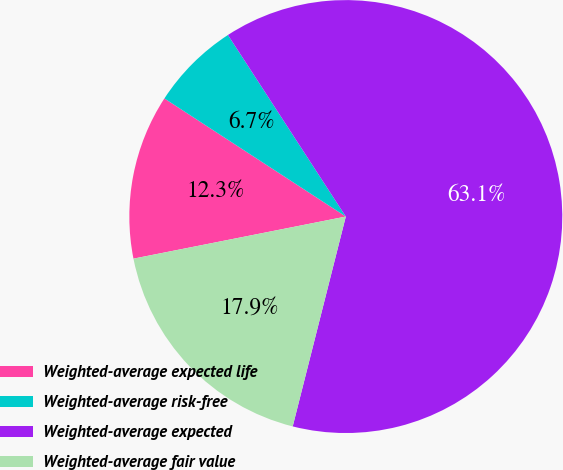Convert chart. <chart><loc_0><loc_0><loc_500><loc_500><pie_chart><fcel>Weighted-average expected life<fcel>Weighted-average risk-free<fcel>Weighted-average expected<fcel>Weighted-average fair value<nl><fcel>12.3%<fcel>6.65%<fcel>63.11%<fcel>17.94%<nl></chart> 